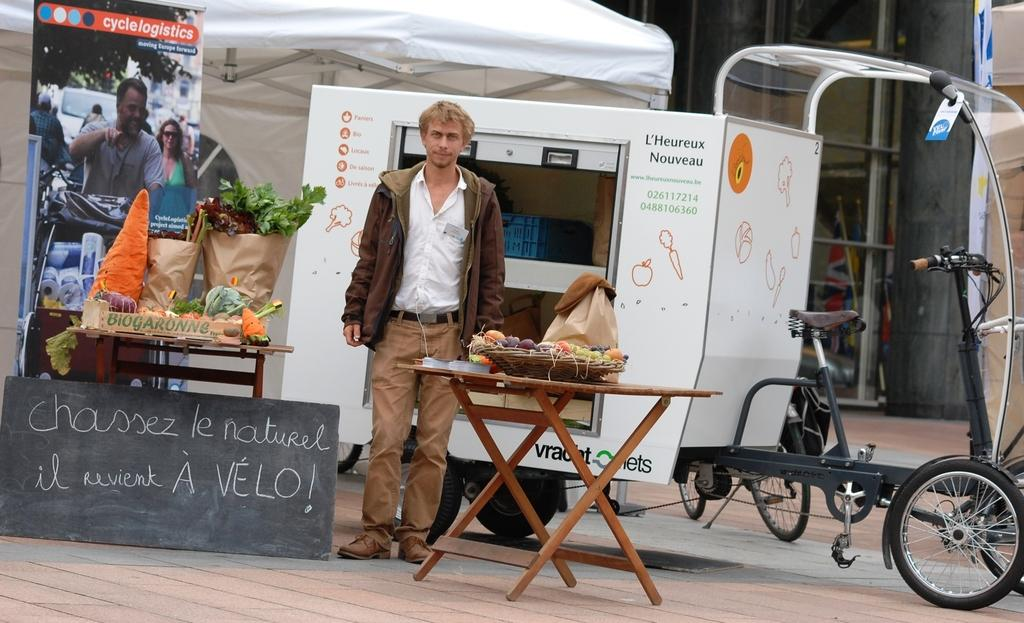What is the position of the man in the image? The man is standing in the image. What is the man standing on? The man is standing on the ground. What is located in front of the man? The man is in front of a table. What can be found on the table? There are objects on the table. What is visible behind the man? There is a vehicle visible behind the man. How does the man use his eyes to hear the sound of the vehicle in the image? The man does not use his eyes to hear the sound of the vehicle in the image; hearing is a function of the ears, not the eyes. 